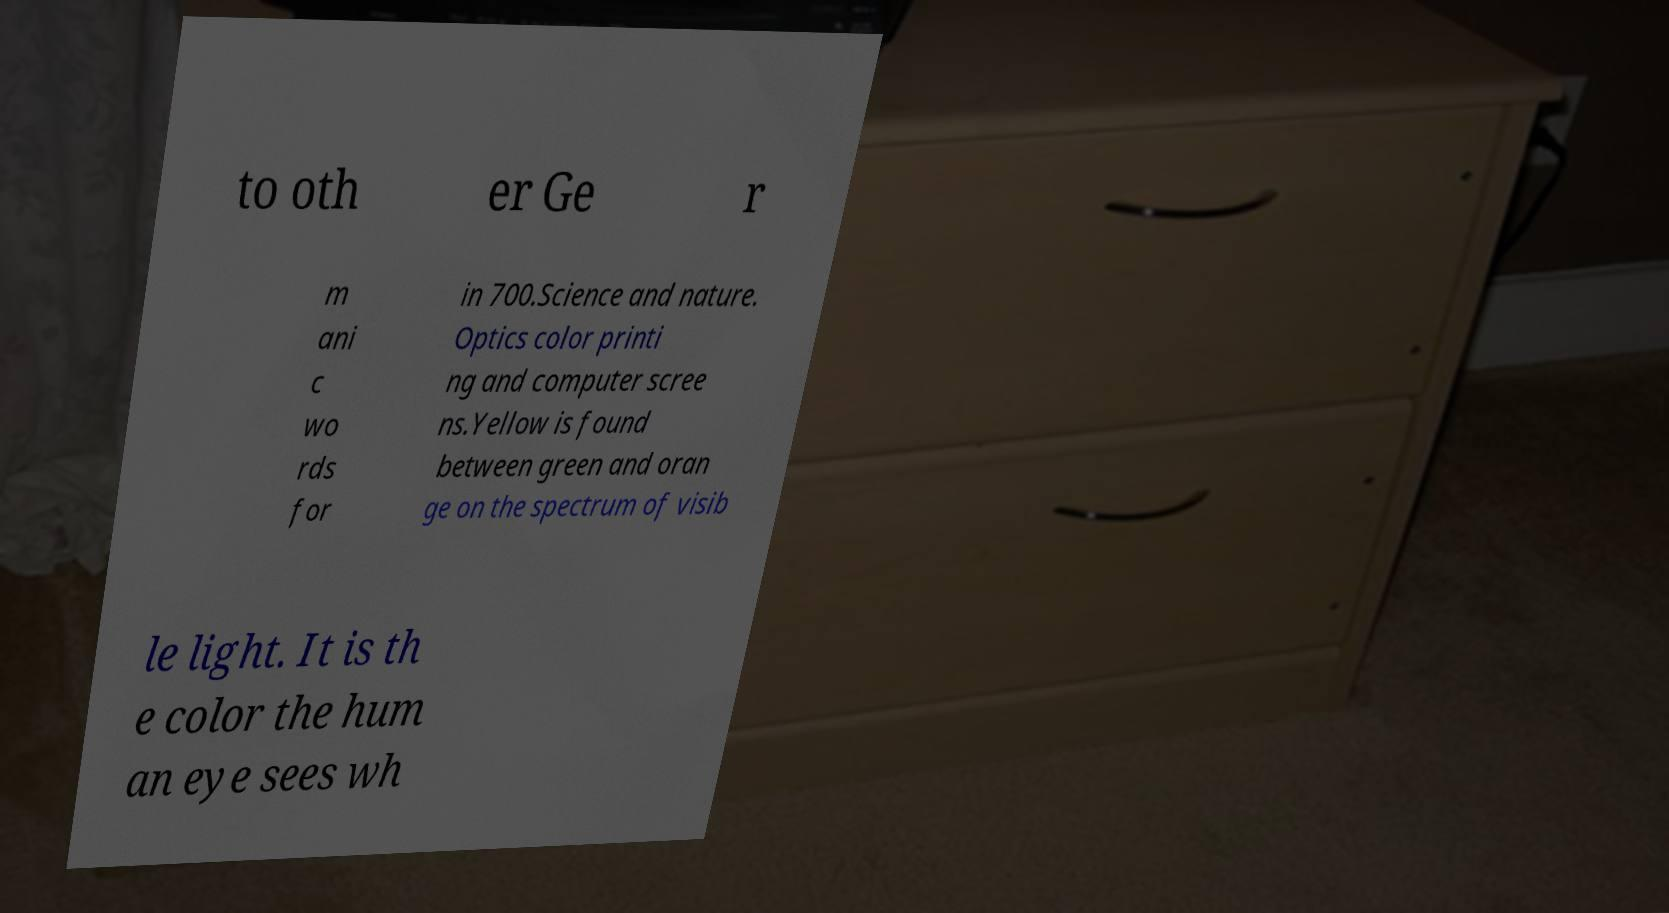I need the written content from this picture converted into text. Can you do that? to oth er Ge r m ani c wo rds for in 700.Science and nature. Optics color printi ng and computer scree ns.Yellow is found between green and oran ge on the spectrum of visib le light. It is th e color the hum an eye sees wh 